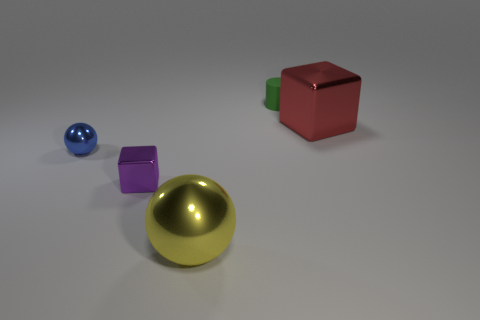Add 3 big blue rubber balls. How many objects exist? 8 Subtract all cylinders. How many objects are left? 4 Subtract 0 gray cylinders. How many objects are left? 5 Subtract all big red metallic blocks. Subtract all gray matte spheres. How many objects are left? 4 Add 1 small green matte things. How many small green matte things are left? 2 Add 5 brown metallic balls. How many brown metallic balls exist? 5 